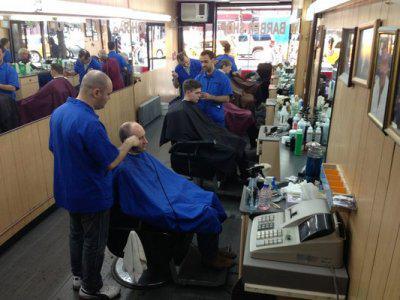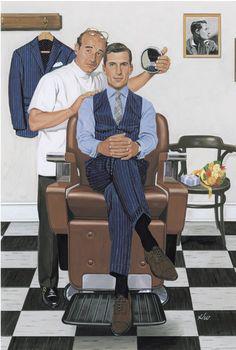The first image is the image on the left, the second image is the image on the right. Evaluate the accuracy of this statement regarding the images: "In the right image, there are two people looking straight ahead.". Is it true? Answer yes or no. Yes. The first image is the image on the left, the second image is the image on the right. Considering the images on both sides, is "Foreground of an image shows a barber in blue by an adult male customer draped in blue." valid? Answer yes or no. Yes. 